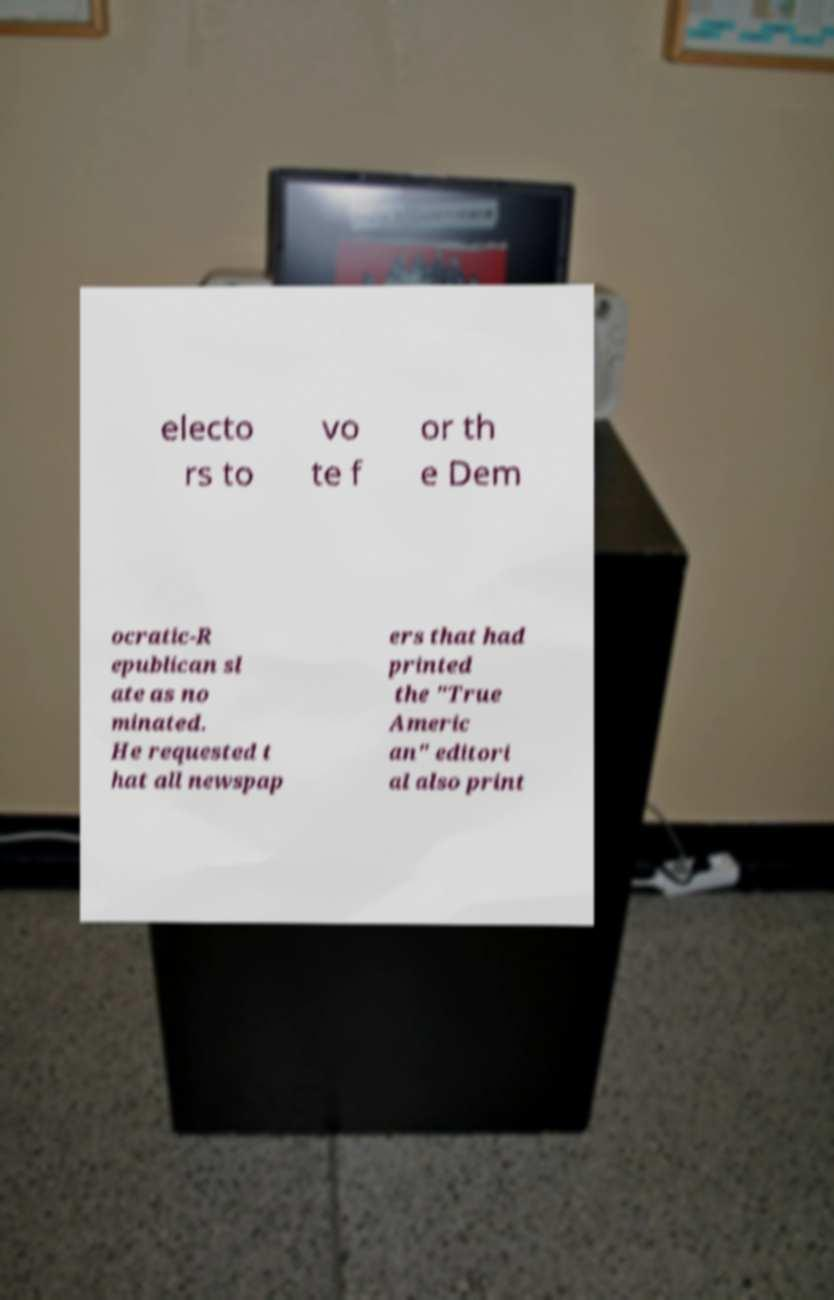Can you read and provide the text displayed in the image?This photo seems to have some interesting text. Can you extract and type it out for me? electo rs to vo te f or th e Dem ocratic-R epublican sl ate as no minated. He requested t hat all newspap ers that had printed the "True Americ an" editori al also print 